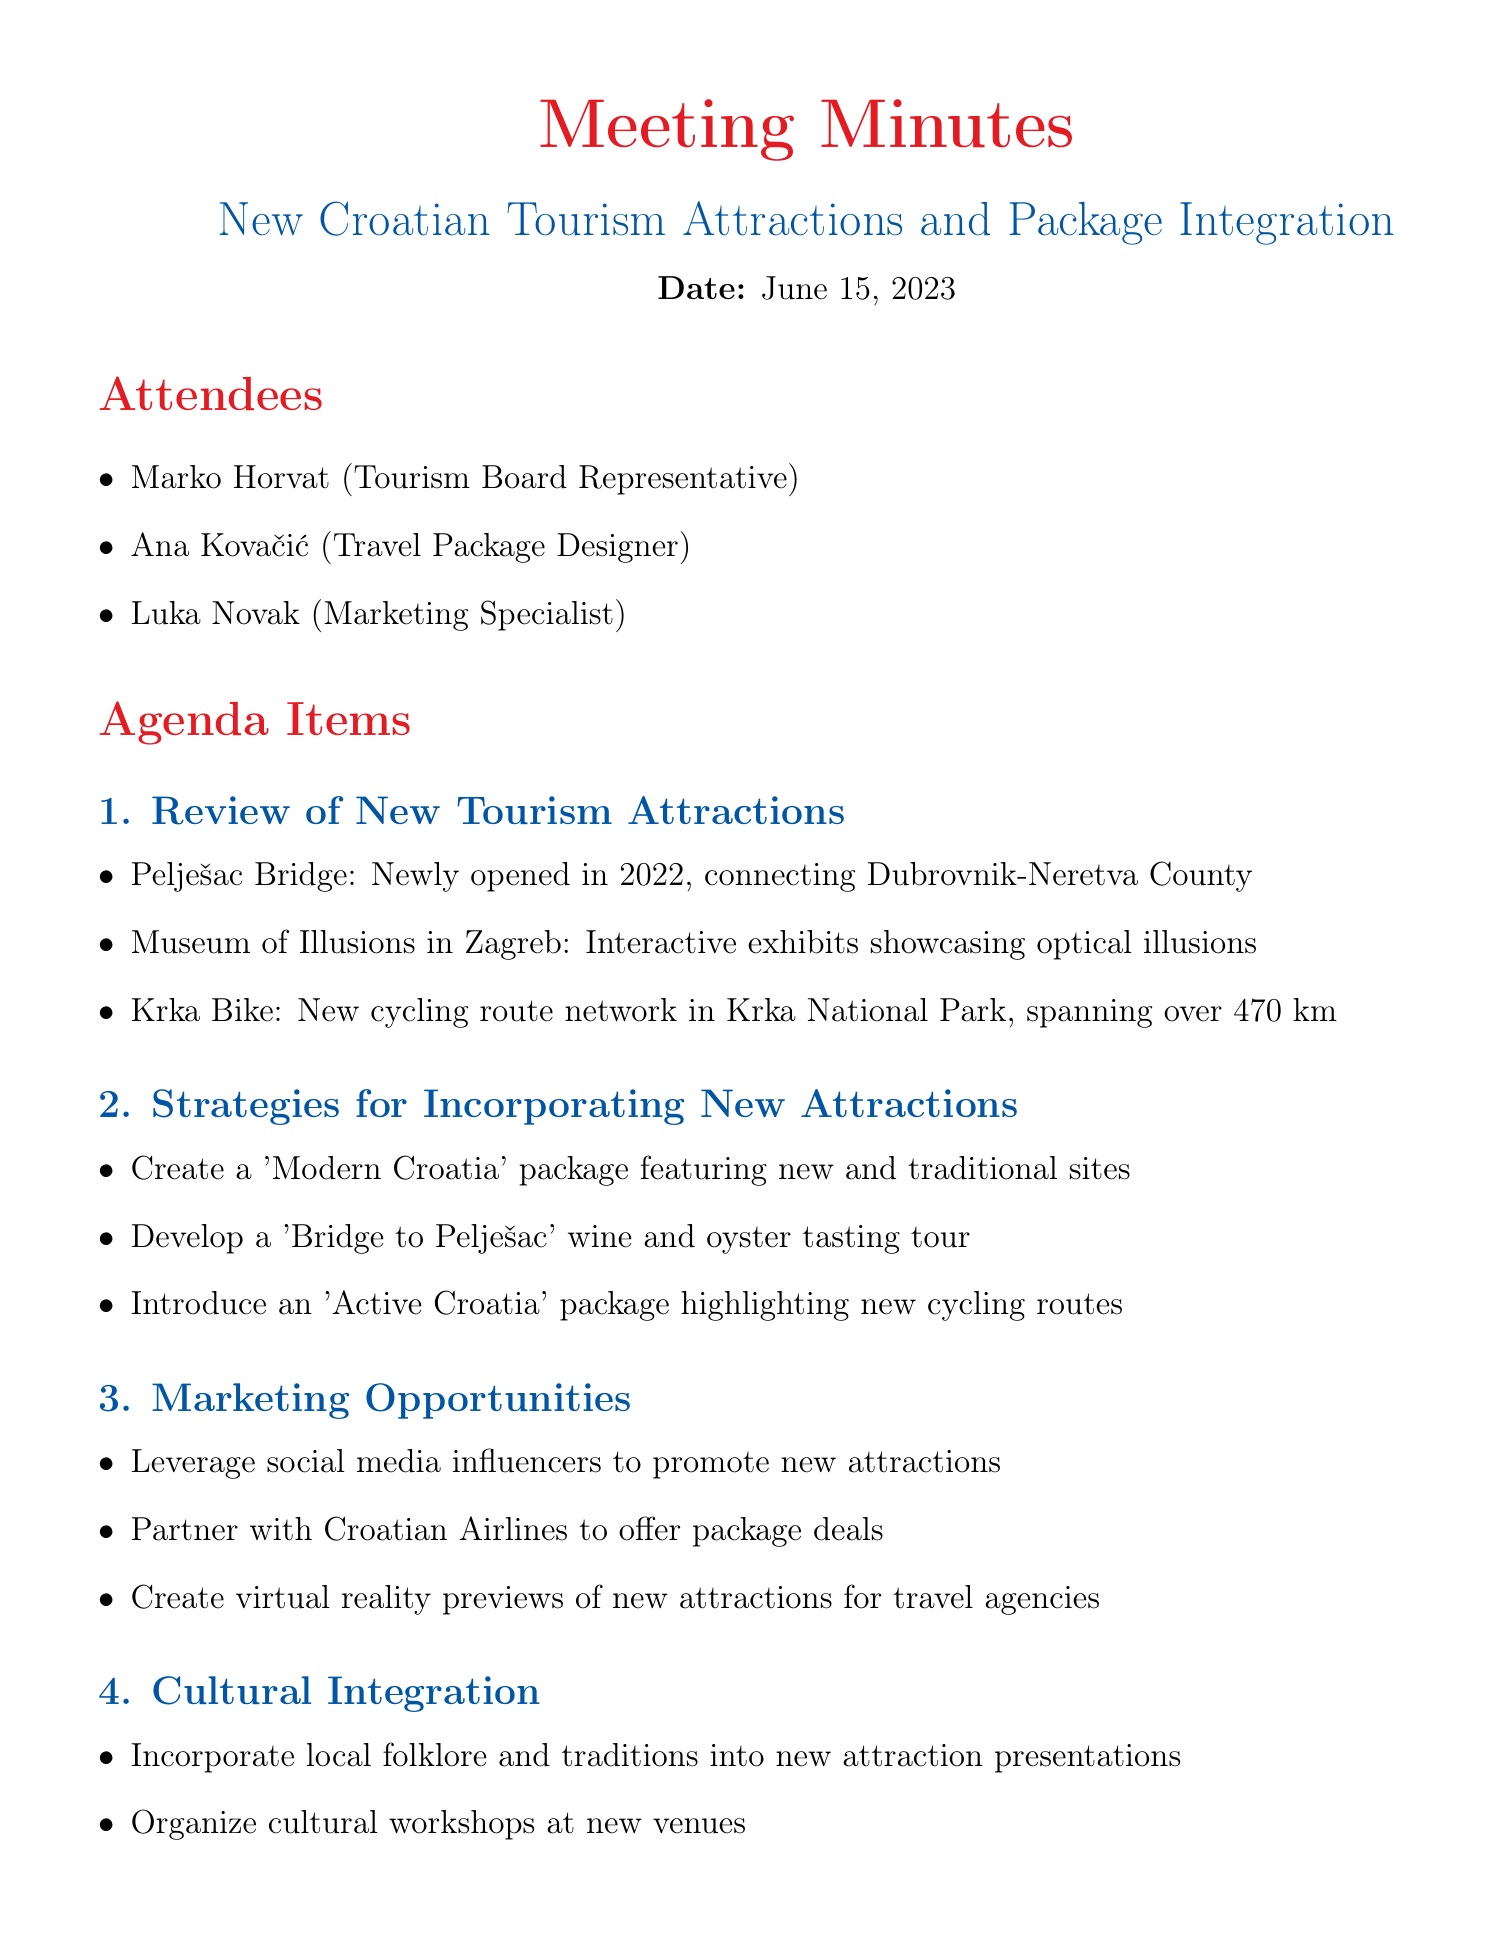What is the date of the meeting? The date of the meeting is explicitly stated in the document.
Answer: June 15, 2023 Who is the marketing specialist attending the meeting? The document lists attendees and identifies their roles.
Answer: Luka Novak What is one new attraction mentioned in the review? The document provides a list of new attractions discussed in the meeting.
Answer: Museum of Illusions in Zagreb What is the name of the proposed 'active' package? The document contains specific package names as part of the proposed strategies.
Answer: Active Croatia How many kilometers does the Krka Bike cycling route network span? The document mentions the length of the cycling route network in Krka National Park.
Answer: 470 km Which attendee is responsible for drafting new travel packages? The action items section specifies responsibilities assigned to attendees.
Answer: Ana What type of promotional technique is suggested for new attractions? The document includes marketing opportunities that suggest specific promotional techniques.
Answer: Social media influencers What is the focus of the proposed cultural workshops? The document refers to cultural integration and examples of workshops planned.
Answer: Traditional dance classes When is the next meeting scheduled? The document includes the date of the next meeting at the end.
Answer: June 29, 2023 